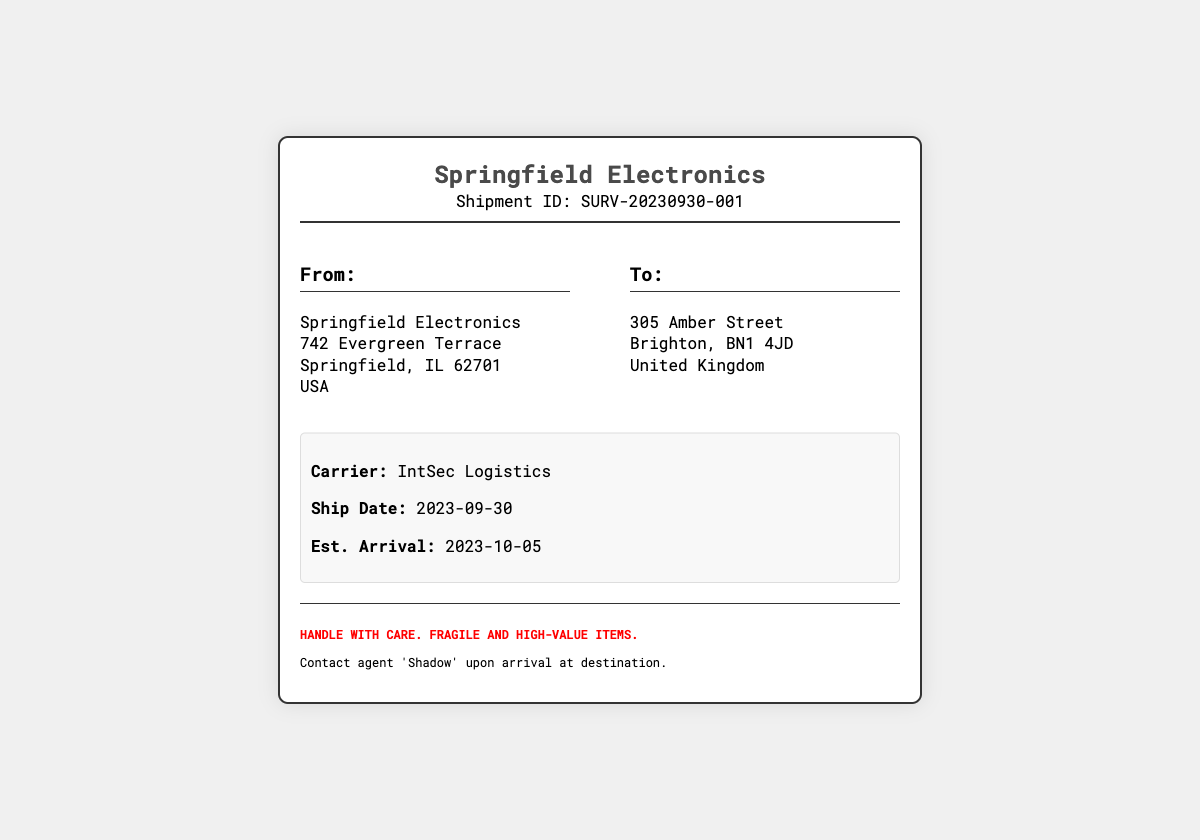what is the shipment ID? The shipment ID is a unique identifier specified in the document, which is SURV-20230930-001.
Answer: SURV-20230930-001 who is the sender? The sender's name and company are located in the "From" address section, which is Springfield Electronics.
Answer: Springfield Electronics what is the destination address? The "To" section provides the destination address, which is 305 Amber Street, Brighton, BN1 4JD, United Kingdom.
Answer: 305 Amber Street, Brighton, BN1 4JD, United Kingdom what is the estimated arrival date? The estimated arrival date is found in the shipment details section, where it states 2023-10-05.
Answer: 2023-10-05 what is the carrier name? The name of the carrier is listed under the shipment details, which is IntSec Logistics.
Answer: IntSec Logistics when was the shipment date? The shipment date is also mentioned in the shipment details, which indicates it was sent on 2023-09-30.
Answer: 2023-09-30 what should be done upon arrival? The instructions section specifies to contact agent 'Shadow' upon arrival at the destination.
Answer: Contact agent 'Shadow' what is the warning provided on the label? The warning is clearly stated in the instructions section, emphasizing that the items are fragile and high-value.
Answer: Handle with care. Fragile and high-value items 